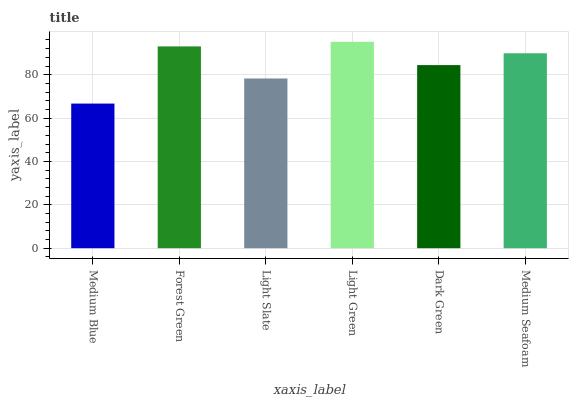Is Medium Blue the minimum?
Answer yes or no. Yes. Is Light Green the maximum?
Answer yes or no. Yes. Is Forest Green the minimum?
Answer yes or no. No. Is Forest Green the maximum?
Answer yes or no. No. Is Forest Green greater than Medium Blue?
Answer yes or no. Yes. Is Medium Blue less than Forest Green?
Answer yes or no. Yes. Is Medium Blue greater than Forest Green?
Answer yes or no. No. Is Forest Green less than Medium Blue?
Answer yes or no. No. Is Medium Seafoam the high median?
Answer yes or no. Yes. Is Dark Green the low median?
Answer yes or no. Yes. Is Medium Blue the high median?
Answer yes or no. No. Is Light Slate the low median?
Answer yes or no. No. 